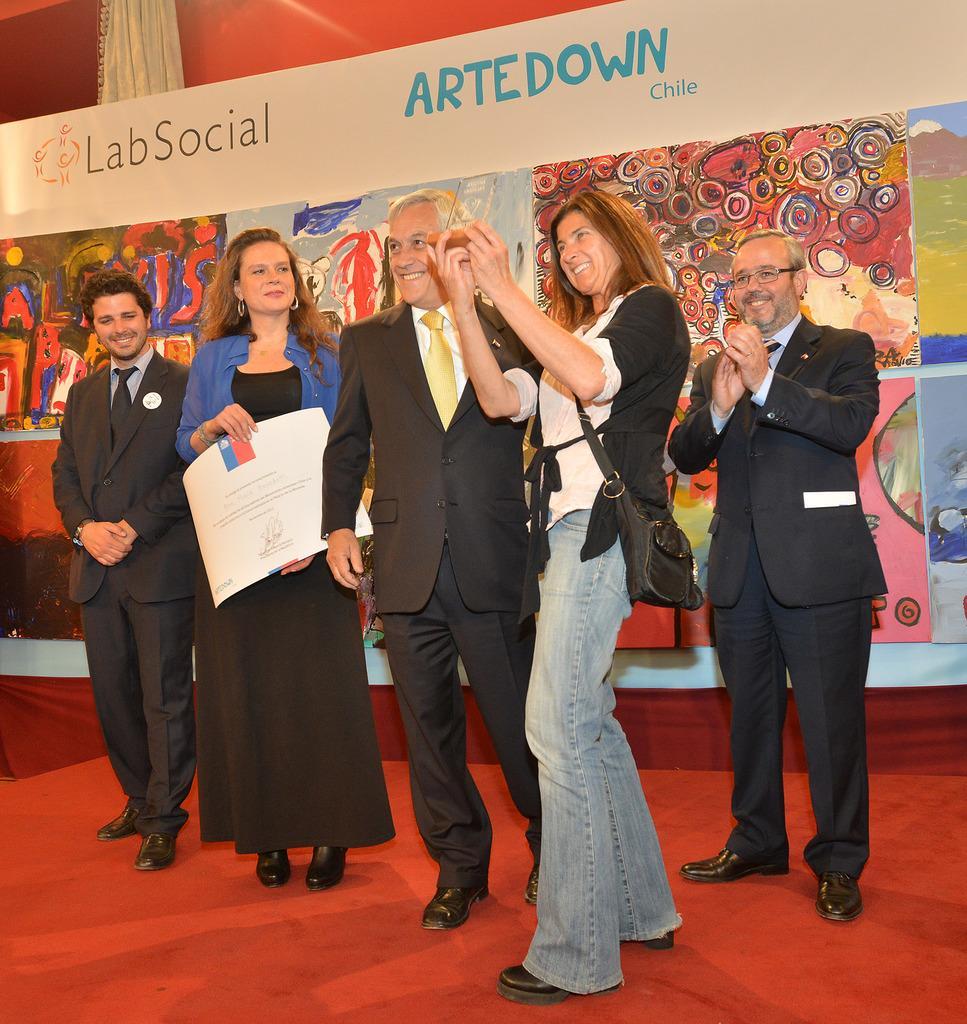Describe this image in one or two sentences. In this image I can see number of persons are standing on the red colored floor and smiling. In the background I can see a huge banner. 